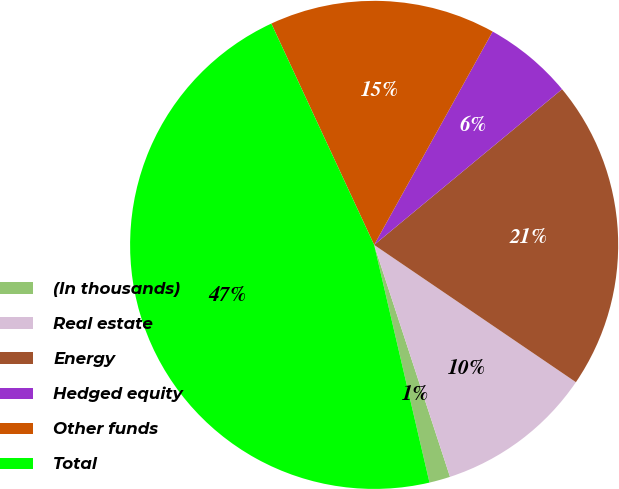Convert chart. <chart><loc_0><loc_0><loc_500><loc_500><pie_chart><fcel>(In thousands)<fcel>Real estate<fcel>Energy<fcel>Hedged equity<fcel>Other funds<fcel>Total<nl><fcel>1.39%<fcel>10.46%<fcel>20.52%<fcel>5.92%<fcel>14.99%<fcel>46.72%<nl></chart> 